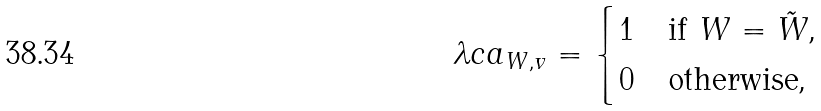Convert formula to latex. <formula><loc_0><loc_0><loc_500><loc_500>\lambda c a _ { W , v } = \begin{cases} 1 & \text {if $W=\tilde{W}$,} \\ 0 & \text {otherwise,} \end{cases}</formula> 